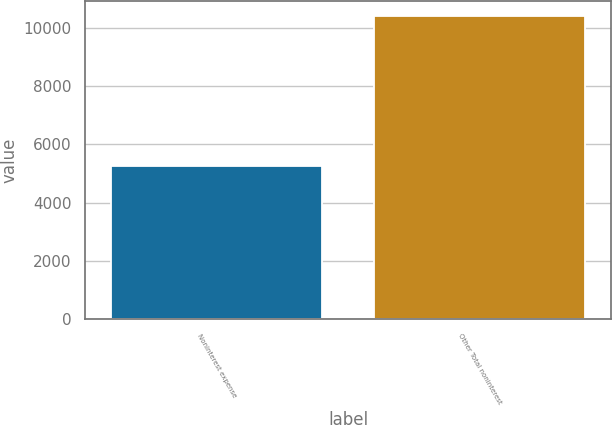Convert chart. <chart><loc_0><loc_0><loc_500><loc_500><bar_chart><fcel>Noninterest expense<fcel>Other Total noninterest<nl><fcel>5268<fcel>10398<nl></chart> 